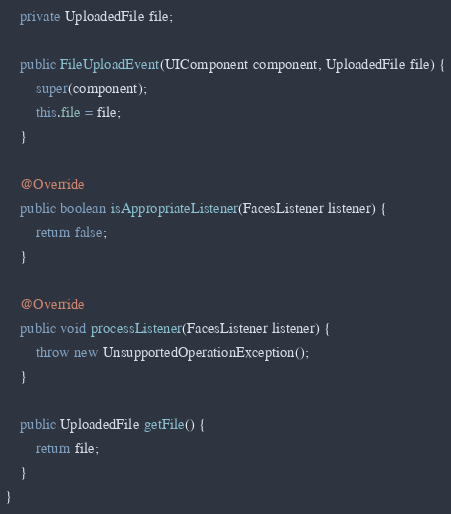Convert code to text. <code><loc_0><loc_0><loc_500><loc_500><_Java_>
    private UploadedFile file;

    public FileUploadEvent(UIComponent component, UploadedFile file) {
        super(component);
        this.file = file;
    }

    @Override
    public boolean isAppropriateListener(FacesListener listener) {
        return false;
    }

    @Override
    public void processListener(FacesListener listener) {
        throw new UnsupportedOperationException();
    }

    public UploadedFile getFile() {
        return file;
    }
}
</code> 